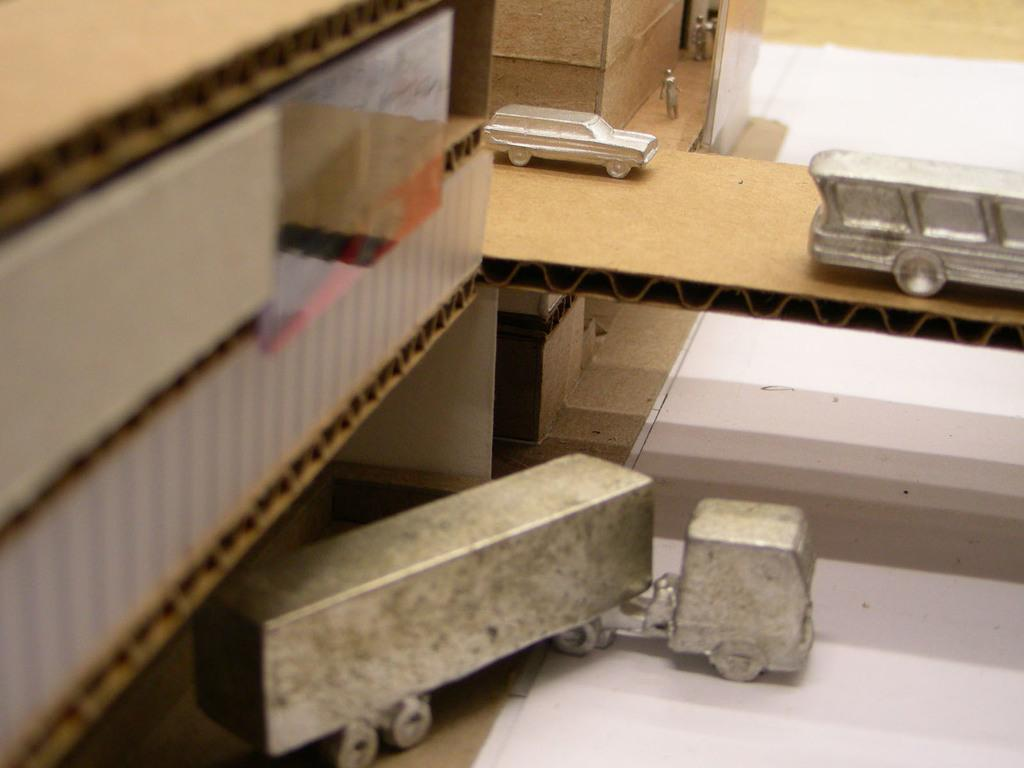What type of objects can be seen in the image? There are cardboard boxes in the image. Are there any living beings depicted in the image? Yes, there are depictions of persons in the image. What else can be seen in the image besides the cardboard boxes and persons? There are vehicles in the image. How are the vehicles positioned in the image? The vehicles are on a path or surface in the image. What type of cub can be seen interacting with the cardboard boxes in the image? There is no cub present in the image; it only features cardboard boxes, depictions of persons, and vehicles. 